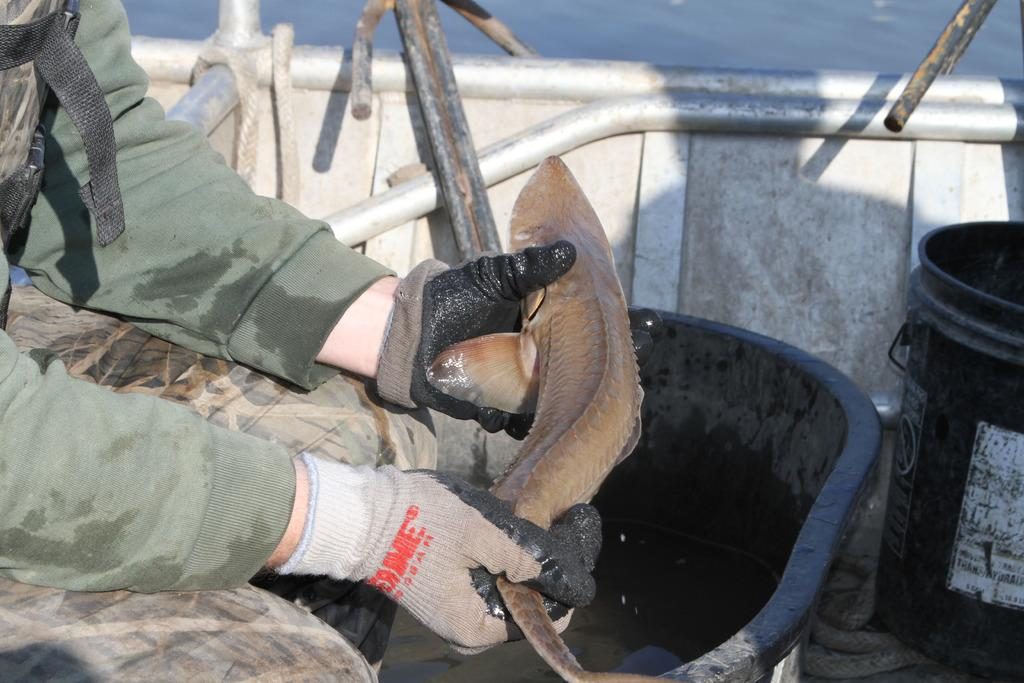What is the main subject of the image? There is a person in the image. What is the person wearing on their hands? The person is wearing gloves. What is the person holding in the image? The person is holding a fish. What type of container is present in the image? There is a tub and a bucket in the image. What can be seen in the background of the image? There is water visible in the background of the image. What type of button is the person wearing on their hair in the image? There is no button or reference to hair in the image; the person is wearing gloves on their hands. 